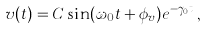<formula> <loc_0><loc_0><loc_500><loc_500>v ( t ) = C \sin ( \omega _ { 0 } t + \phi _ { v } ) e ^ { - \gamma _ { 0 } t } \, ,</formula> 